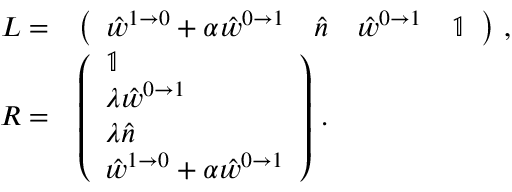Convert formula to latex. <formula><loc_0><loc_0><loc_500><loc_500>\begin{array} { r l } { L = } & { \left ( \begin{array} { l l l l } { \hat { w } ^ { 1 \to 0 } + \alpha \hat { w } ^ { 0 \to 1 } } & { \hat { n } } & { \hat { w } ^ { 0 \to 1 } } & { \mathbb { 1 } } \end{array} \right ) \, , } \\ { R = } & { \left ( \begin{array} { l } { \mathbb { 1 } } \\ { \lambda \hat { w } ^ { 0 \to 1 } } \\ { \lambda \hat { n } } \\ { \hat { w } ^ { 1 \to 0 } + \alpha \hat { w } ^ { 0 \to 1 } } \end{array} \right ) \, . } \end{array}</formula> 